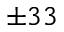Convert formula to latex. <formula><loc_0><loc_0><loc_500><loc_500>\pm 3 3</formula> 